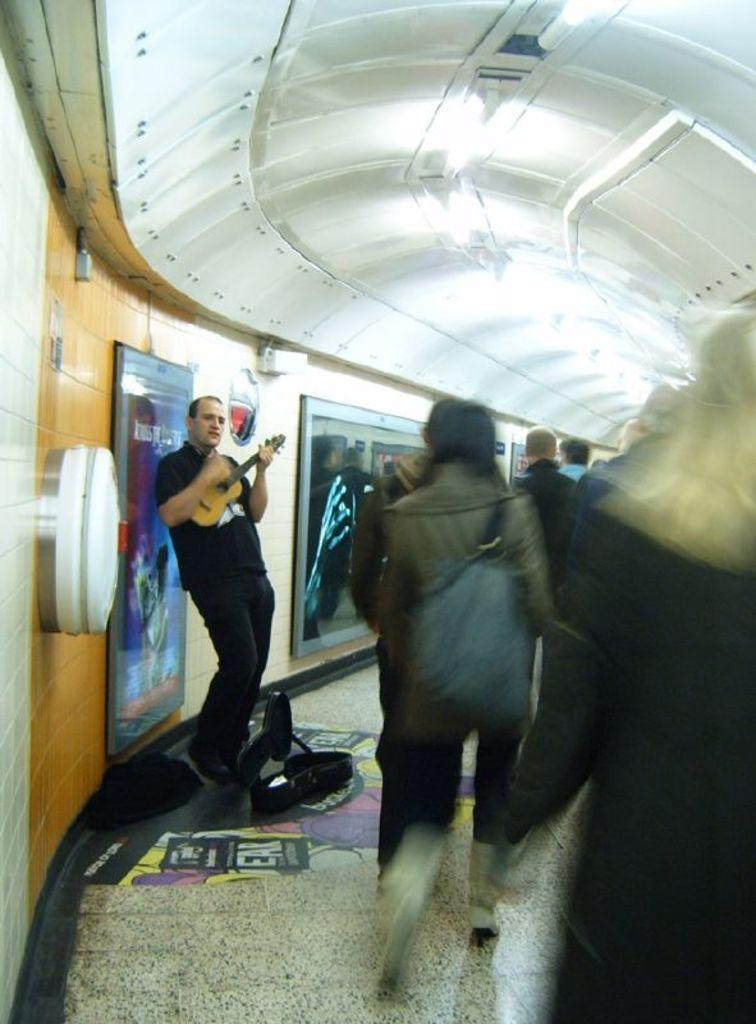Who or what can be seen in the image? There are people in the image. What else is present in the image besides the people? There is a banner in the image. Can you describe the man in the image? A man is standing in the image, and he is holding a guitar. What type of payment system is being used by the man in the image? There is no payment system mentioned or depicted in the image; the man is simply holding a guitar. 